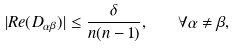Convert formula to latex. <formula><loc_0><loc_0><loc_500><loc_500>| R e ( D _ { \alpha \beta } ) | \leq \frac { \delta } { n ( n - 1 ) } , \quad \forall \alpha \neq \beta ,</formula> 